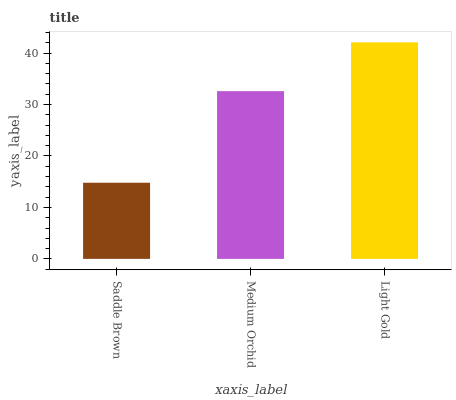Is Saddle Brown the minimum?
Answer yes or no. Yes. Is Light Gold the maximum?
Answer yes or no. Yes. Is Medium Orchid the minimum?
Answer yes or no. No. Is Medium Orchid the maximum?
Answer yes or no. No. Is Medium Orchid greater than Saddle Brown?
Answer yes or no. Yes. Is Saddle Brown less than Medium Orchid?
Answer yes or no. Yes. Is Saddle Brown greater than Medium Orchid?
Answer yes or no. No. Is Medium Orchid less than Saddle Brown?
Answer yes or no. No. Is Medium Orchid the high median?
Answer yes or no. Yes. Is Medium Orchid the low median?
Answer yes or no. Yes. Is Saddle Brown the high median?
Answer yes or no. No. Is Saddle Brown the low median?
Answer yes or no. No. 